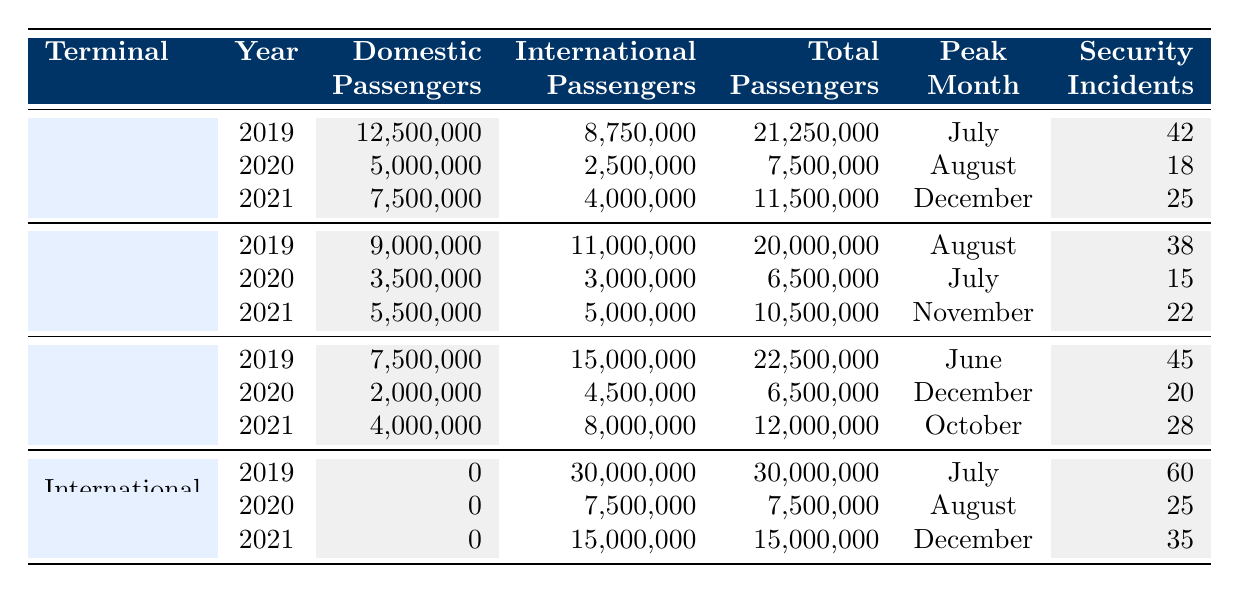What was the total passenger traffic for Terminal 2 in 2021? In the table, for Terminal 2 in 2021, the total passenger count is listed as 10,500,000.
Answer: 10,500,000 Which terminal had the highest number of security incidents in 2019? By looking at the table, the International Terminal had the highest security incidents in 2019, with a total of 60 incidents.
Answer: International Terminal What percentage of passengers in Terminal 3 were international in 2020? In 2020, Terminal 3 had 6,500,000 passengers, out of which 4,500,000 were international. To find the percentage, calculate (4,500,000 / 6,500,000) * 100 = 69.23%.
Answer: 69.23% What was the peak month for passenger traffic in Terminal 1 during the years listed? From the table, the peak month for Terminal 1 across 2019, 2020, and 2021 was July in 2019.
Answer: July How many more domestic passengers did Terminal 1 have than Terminal 2 in 2019? In 2019, Terminal 1 had 12,500,000 domestic passengers while Terminal 2 had 9,000,000. The difference is 12,500,000 - 9,000,000 = 3,500,000.
Answer: 3,500,000 Was the total passenger traffic for the International Terminal in 2020 greater than that of Terminal 2 in the same year? According to the table, the International Terminal had 7,500,000 passengers in 2020 while Terminal 2 had 6,500,000. Thus, yes, it was greater.
Answer: Yes Which terminal saw the largest decrease in total passengers from 2019 to 2020? For 2019, Terminal 1 had 21,250,000 total passengers, which decreased to 7,500,000 in 2020. The decrease equals 21,250,000 - 7,500,000 = 13,750,000. Comparing Terminal 2 and Terminal 3 also shows decreases, but they were smaller.
Answer: Terminal 1 If we consider all terminals, what was the total number of passengers in 2021? For 2021, add up the total passengers for all terminals: 11,500,000 (Terminal 1) + 10,500,000 (Terminal 2) + 12,000,000 (Terminal 3) + 15,000,000 (International) = 49,000,000.
Answer: 49,000,000 What is the average number of security incidents per terminal in 2020? The total number of security incidents in 2020 for all terminals was 18 (Terminal 1) + 15 (Terminal 2) + 20 (Terminal 3) + 25 (International) = 78. There are 4 terminals, so the average is 78 / 4 = 19.5.
Answer: 19.5 Did the International Terminal have any domestic passengers in 2021? According to the table, the International Terminal had 0 domestic passengers in 2021.
Answer: No 